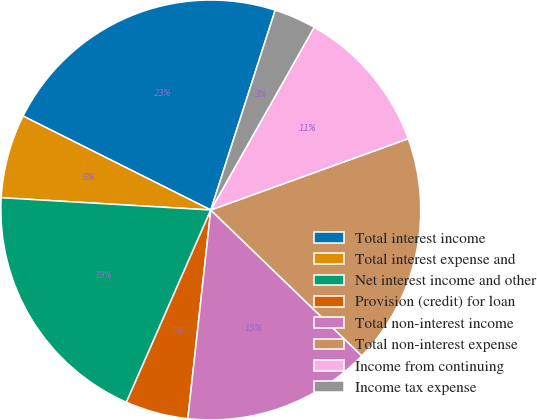<chart> <loc_0><loc_0><loc_500><loc_500><pie_chart><fcel>Total interest income<fcel>Total interest expense and<fcel>Net interest income and other<fcel>Provision (credit) for loan<fcel>Total non-interest income<fcel>Total non-interest expense<fcel>Income from continuing<fcel>Income tax expense<nl><fcel>22.58%<fcel>6.45%<fcel>19.35%<fcel>4.84%<fcel>14.52%<fcel>17.74%<fcel>11.29%<fcel>3.23%<nl></chart> 